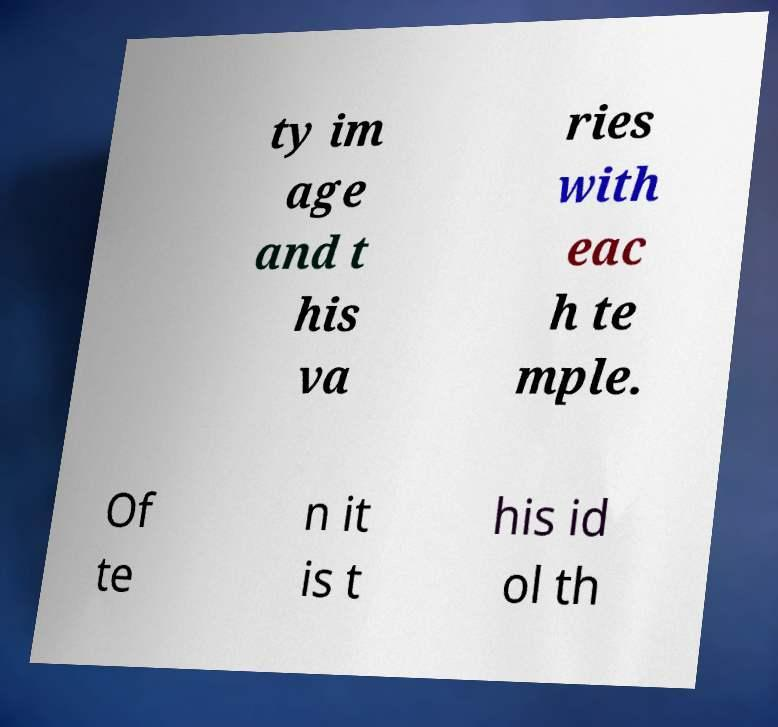Can you accurately transcribe the text from the provided image for me? ty im age and t his va ries with eac h te mple. Of te n it is t his id ol th 